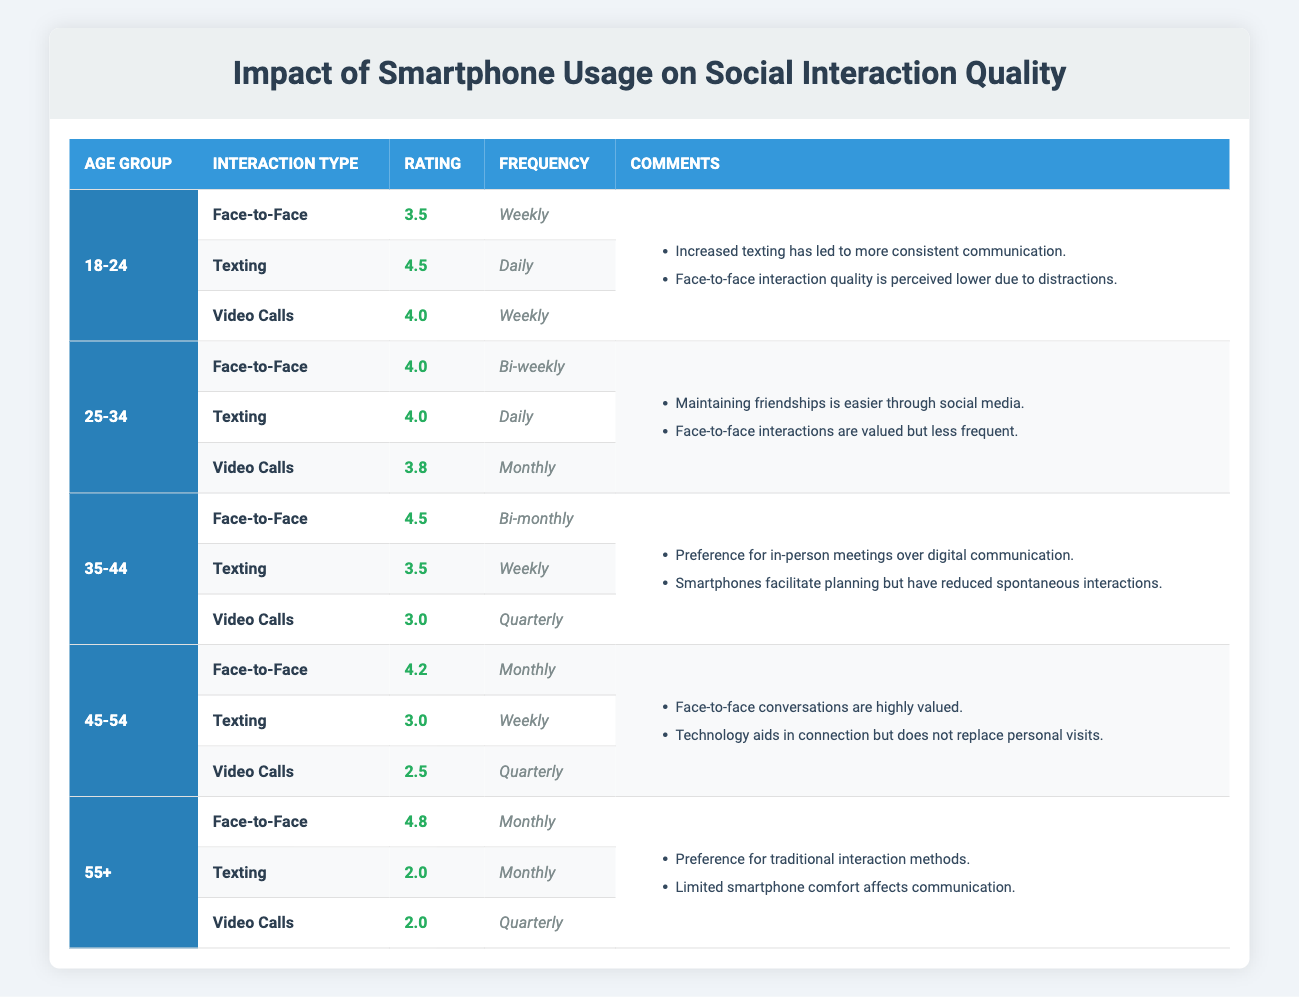What is the frequency of face-to-face interactions for the age group 25-34? In the table, under the age group 25-34, the interaction type "Face-to-Face" has a frequency labeled as "Bi-weekly".
Answer: Bi-weekly What is the rating for texting among individuals aged 35-44? Looking at the age group 35-44 in the table, the "Texting" interaction type has a rating of 3.5.
Answer: 3.5 Is the rating for video calls among those aged 45-54 higher than for texting? In the 45-54 age group, the rating for "Video Calls" is 2.5 while the rating for "Texting" is 3.0. Since 2.5 is less than 3.0, the statement is false.
Answer: No What is the average rating for face-to-face interactions across all age groups? The ratings for face-to-face interactions are 3.5, 4.0, 4.5, 4.2, and 4.8. The sum is 3.5 + 4.0 + 4.5 + 4.2 + 4.8 = 20. The average is 20 divided by 5, which equals 4.0.
Answer: 4.0 Which age group has the highest rating for face-to-face interactions? By checking the ratings in the table, the age group 55+ has the highest face-to-face rating of 4.8.
Answer: 55+ What is the most frequently mentioned interaction type for the age group 18-24? In the 18-24 age group, the "Texting" interaction type has a frequency of "Daily", which appears more often than others (Weekly for Face-to-Face and Video Calls). Therefore, Texting is the most frequent.
Answer: Texting What is the frequency of video calls for individuals aged 55 and older? For the age group 55+, the frequency for "Video Calls" is listed as "Quarterly".
Answer: Quarterly Among ages 35-44, which interaction type has the lowest rating? Checking the ratings for age group 35-44, we see that "Video Calls" has the lowest rating at 3.0 compared to Face-to-Face (4.5) and Texting (3.5).
Answer: Video Calls Are face-to-face interactions valued the same across all age groups? The comments indicate that older age groups value face-to-face interactions significantly with high ratings, while younger groups express a slightly lower perception likely due to distractions. Therefore, no, they are not valued the same.
Answer: No 